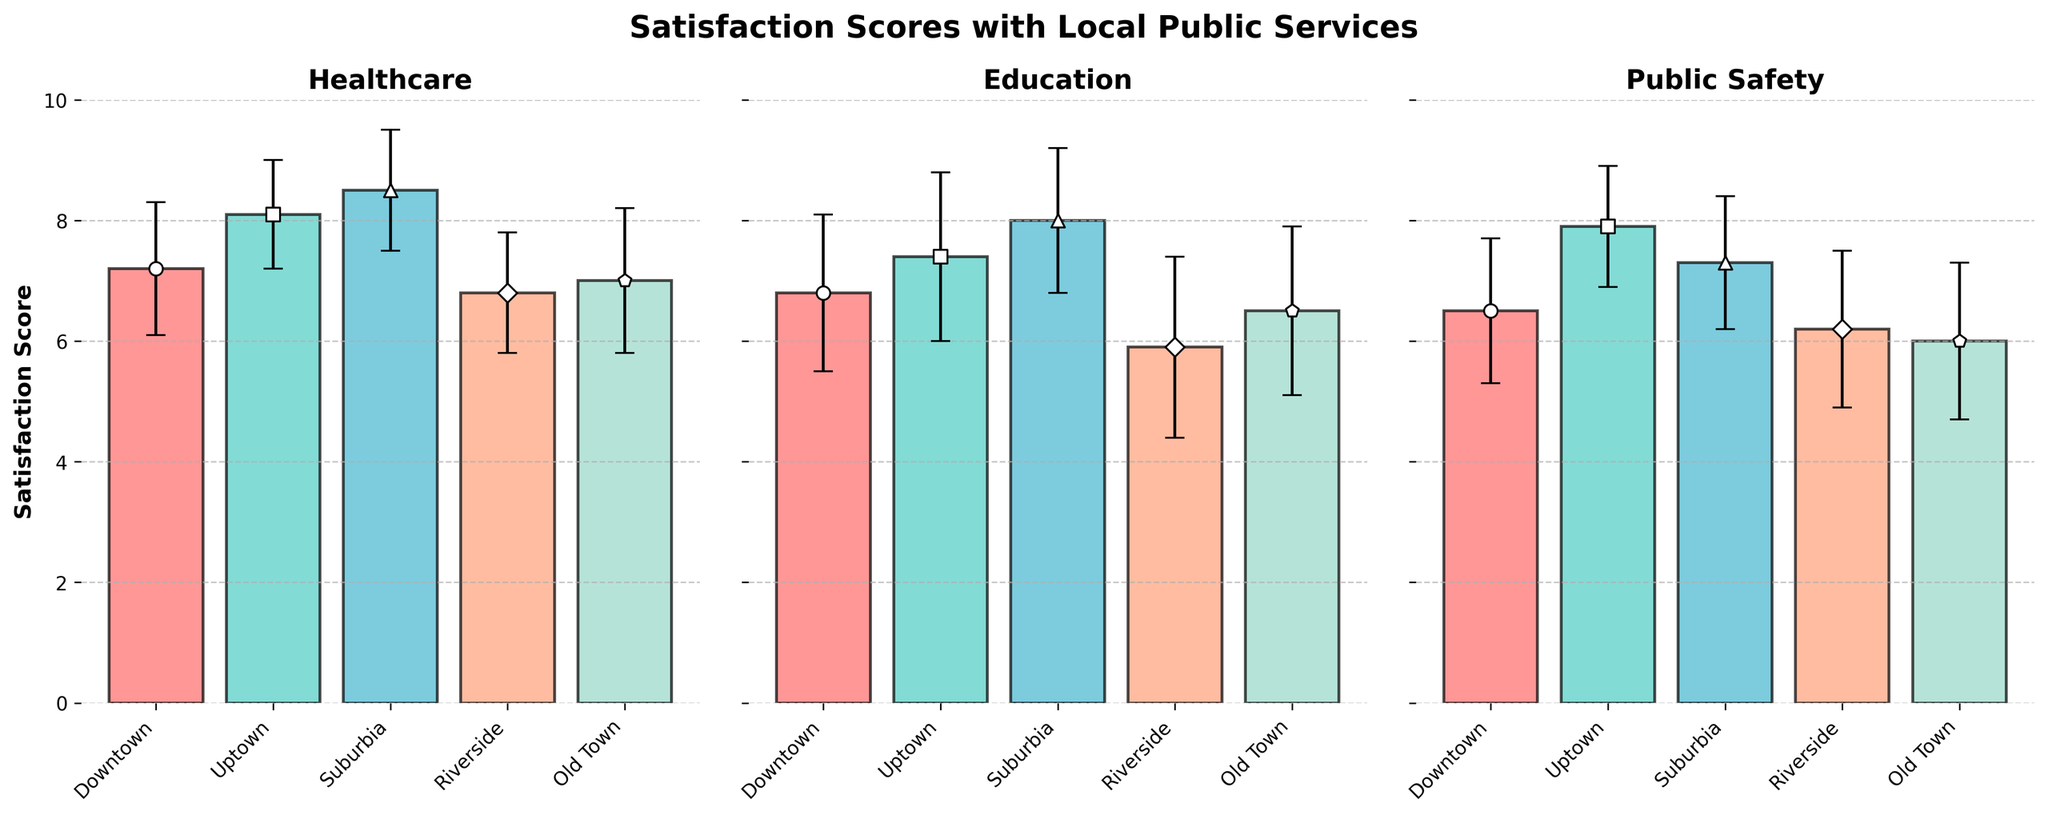What's the title of the figure? The title is always located at the top center of the chart. In this case, it reads "Satisfaction Scores with Local Public Services," indicating the purpose of the visual representation.
Answer: Satisfaction Scores with Local Public Services How many subplots are in the figure? One can see three separate charts arranged next to each other, each representing a different public service.
Answer: 3 Which neighborhood has the highest satisfaction score for Healthcare? Observation shows that the bar for Healthcare in Suburbia reaches the highest point on the y-axis compared to other neighborhoods.
Answer: Suburbia Which neighborhood has the lowest satisfaction score for Education? Examining the heights of the bars in the Education subplot, Riverside has the lowest bar, indicating the lowest mean satisfaction score.
Answer: Riverside Is Uptown's satisfaction score for Public Safety greater than Downtown's? Comparing the heights of the bars for Public Safety in Uptown and Downtown within their subplot, Uptown's bar is higher.
Answer: Yes What is the average satisfaction score for Healthcare across all neighborhoods? To find the average, sum the mean scores for Healthcare in each neighborhood (7.2 + 8.1 + 8.5 + 6.8 + 7.0) and divide by 5.
Answer: 7.52 Calculate the difference in satisfaction scores between Education and Public Safety in Old Town. Identify the mean scores for Education (6.5) and Public Safety (6.0) in Old Town, then subtract Public Safety from Education.
Answer: 0.5 Which public service generally has the highest satisfaction scores across all neighborhoods? By examining the heights of the bars across all three subplots, Healthcare typically has the highest bars in most neighborhoods except for Riverside.
Answer: Healthcare Considering error bars, which neighborhood shows the highest variability in satisfaction scores for Education? Looking at the length of error bars representing standard deviation in the Education subplot, Riverside has the longest error bars.
Answer: Riverside Are the satisfaction scores for Public Safety more consistent (lower standard deviations) in Downtown or Uptown? Observing the error bars for Public Safety, the length of the bars in Downtown is longer than those in Uptown, indicating higher variability in Downtown.
Answer: Uptown 